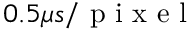Convert formula to latex. <formula><loc_0><loc_0><loc_500><loc_500>0 . 5 \mu s / p i x e l</formula> 